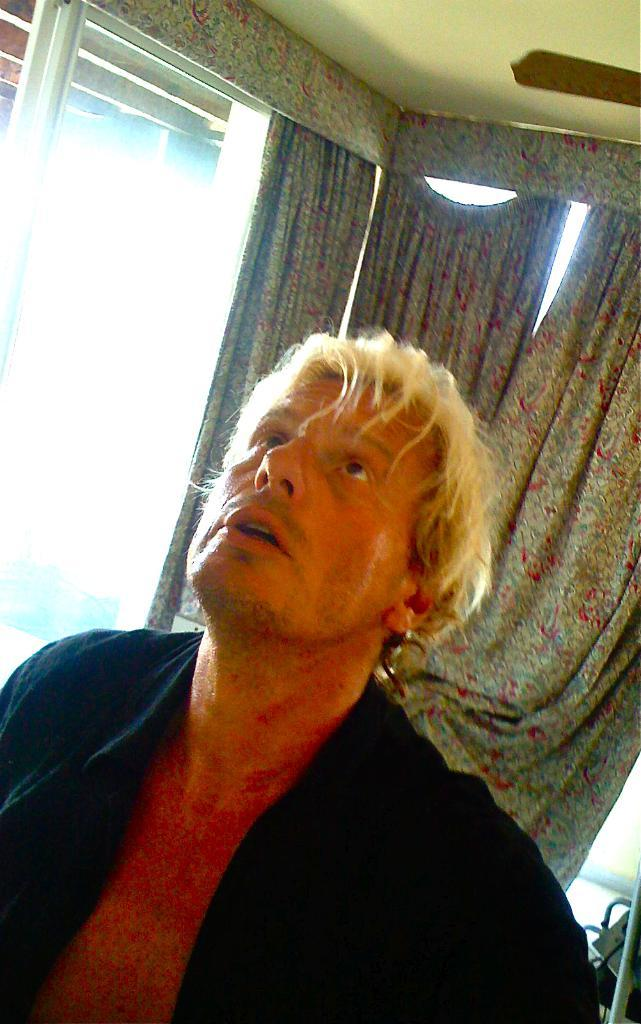Where is the person located in the image? The person is in the left corner of the image. What is the person wearing in the image? The person is wearing a black dress. What can be seen in the background of the image? There is a glass window and curtains in the background of the image. What type of berry is the person holding in the image? There is no berry present in the image; the person is not holding anything. 